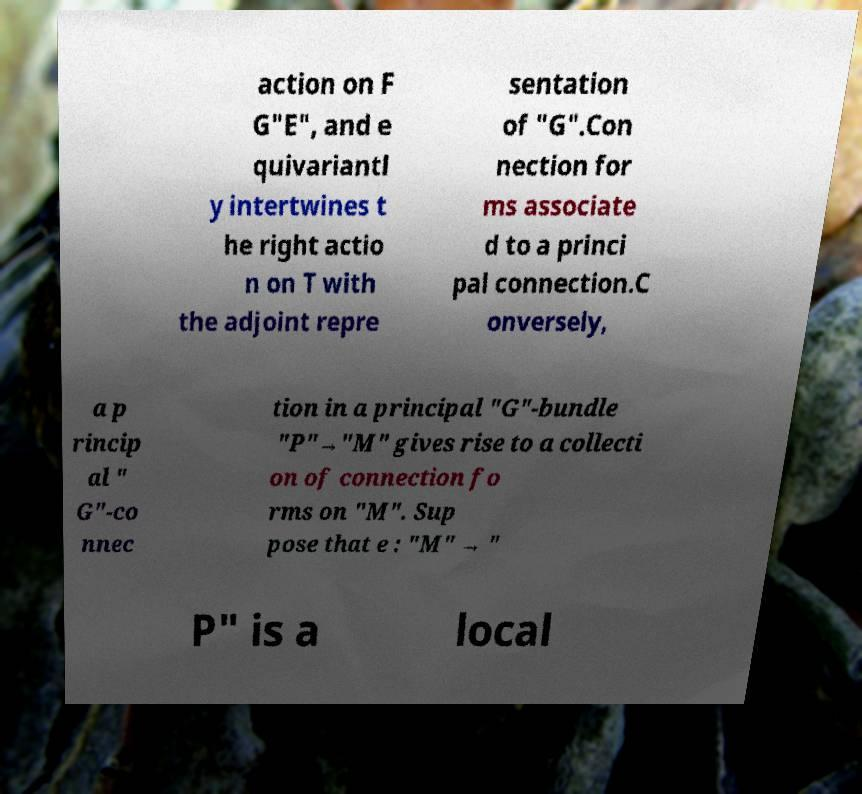Please read and relay the text visible in this image. What does it say? action on F G"E", and e quivariantl y intertwines t he right actio n on T with the adjoint repre sentation of "G".Con nection for ms associate d to a princi pal connection.C onversely, a p rincip al " G"-co nnec tion in a principal "G"-bundle "P"→"M" gives rise to a collecti on of connection fo rms on "M". Sup pose that e : "M" → " P" is a local 